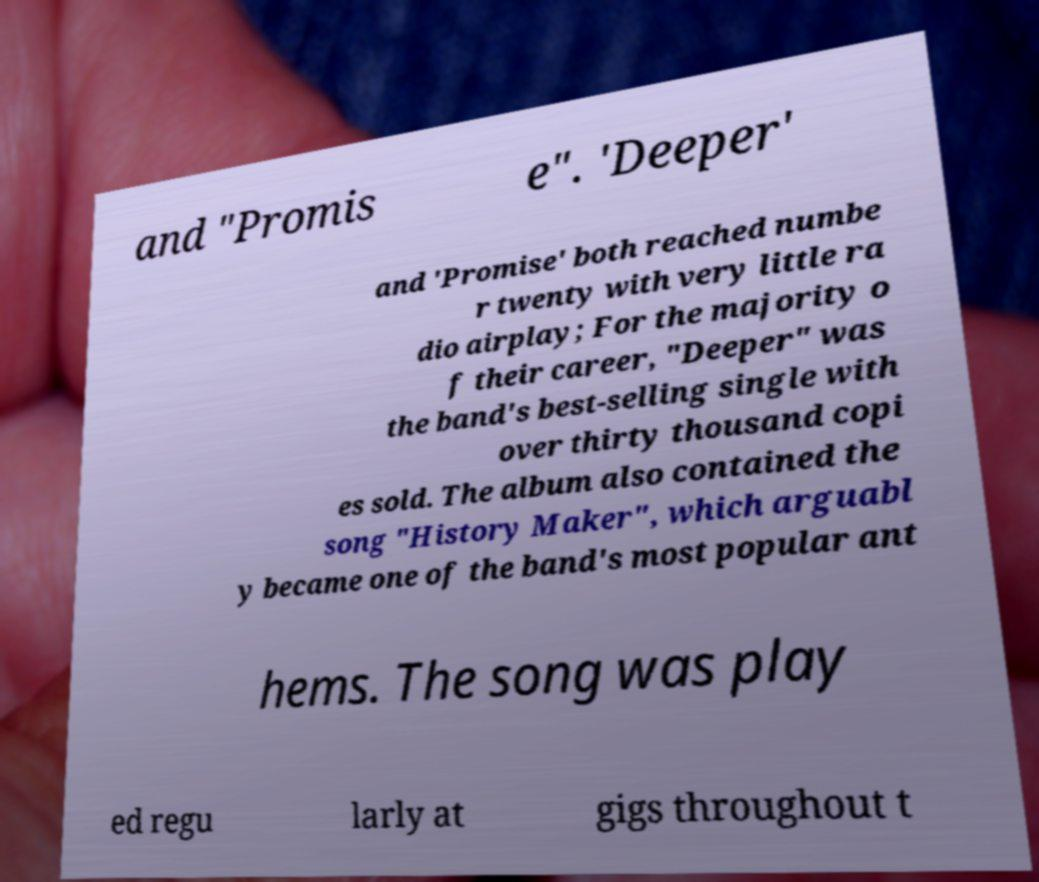I need the written content from this picture converted into text. Can you do that? and "Promis e". 'Deeper' and 'Promise' both reached numbe r twenty with very little ra dio airplay; For the majority o f their career, "Deeper" was the band's best-selling single with over thirty thousand copi es sold. The album also contained the song "History Maker", which arguabl y became one of the band's most popular ant hems. The song was play ed regu larly at gigs throughout t 